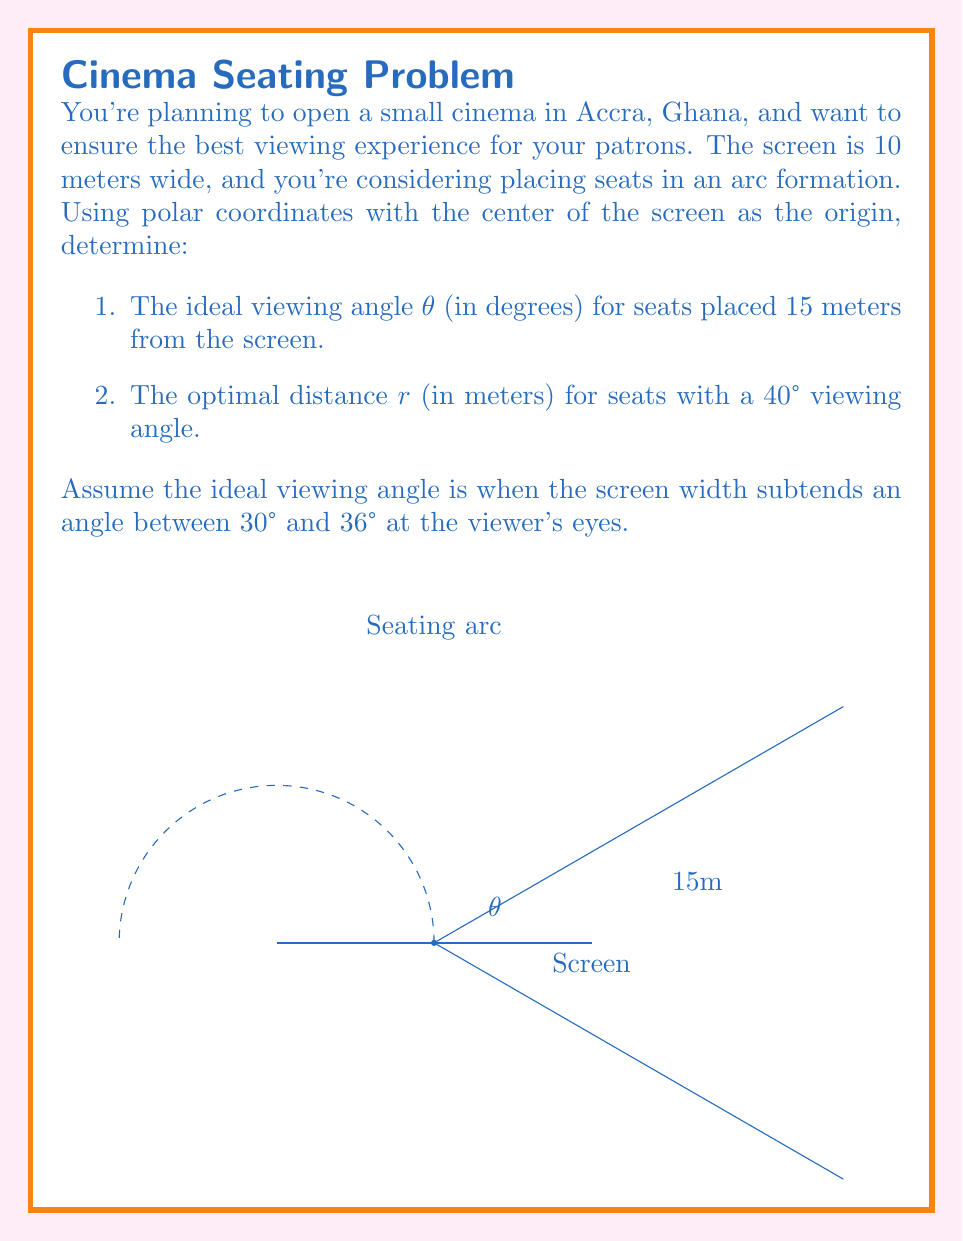What is the answer to this math problem? Let's approach this problem step-by-step:

1. Ideal viewing angle for seats 15 meters from the screen:

   We can use the formula for the angle subtended by an object:
   $$ \theta = 2 \arctan(\frac{w}{2d}) $$
   where w is the width of the screen and d is the distance from the screen.

   Substituting our values:
   $$ \theta = 2 \arctan(\frac{10}{2 \cdot 15}) = 2 \arctan(0.3333) $$
   $$ \theta \approx 36.87° $$

   This is just slightly above our ideal range, so it's acceptable.

2. Optimal distance for seats with a 40° viewing angle:

   We can rearrange the same formula to solve for d:
   $$ d = \frac{w}{2 \tan(\frac{\theta}{2})} $$

   Substituting our values:
   $$ r = \frac{10}{2 \tan(\frac{40°}{2})} = \frac{10}{2 \tan(20°)} $$
   $$ r \approx 13.74 \text{ meters} $$

To verify if these results are within the ideal range:

For the 15m distance:
$$ 30° < 36.87° < 36° $$
The angle is slightly above the ideal range but close enough to be acceptable.

For the 40° viewing angle:
$$ 30° < 40° < 36° $$
This angle is outside the ideal range, but the question asks for this specific angle.
Answer: 1. $\theta \approx 36.87°$
2. $r \approx 13.74 \text{ meters}$ 